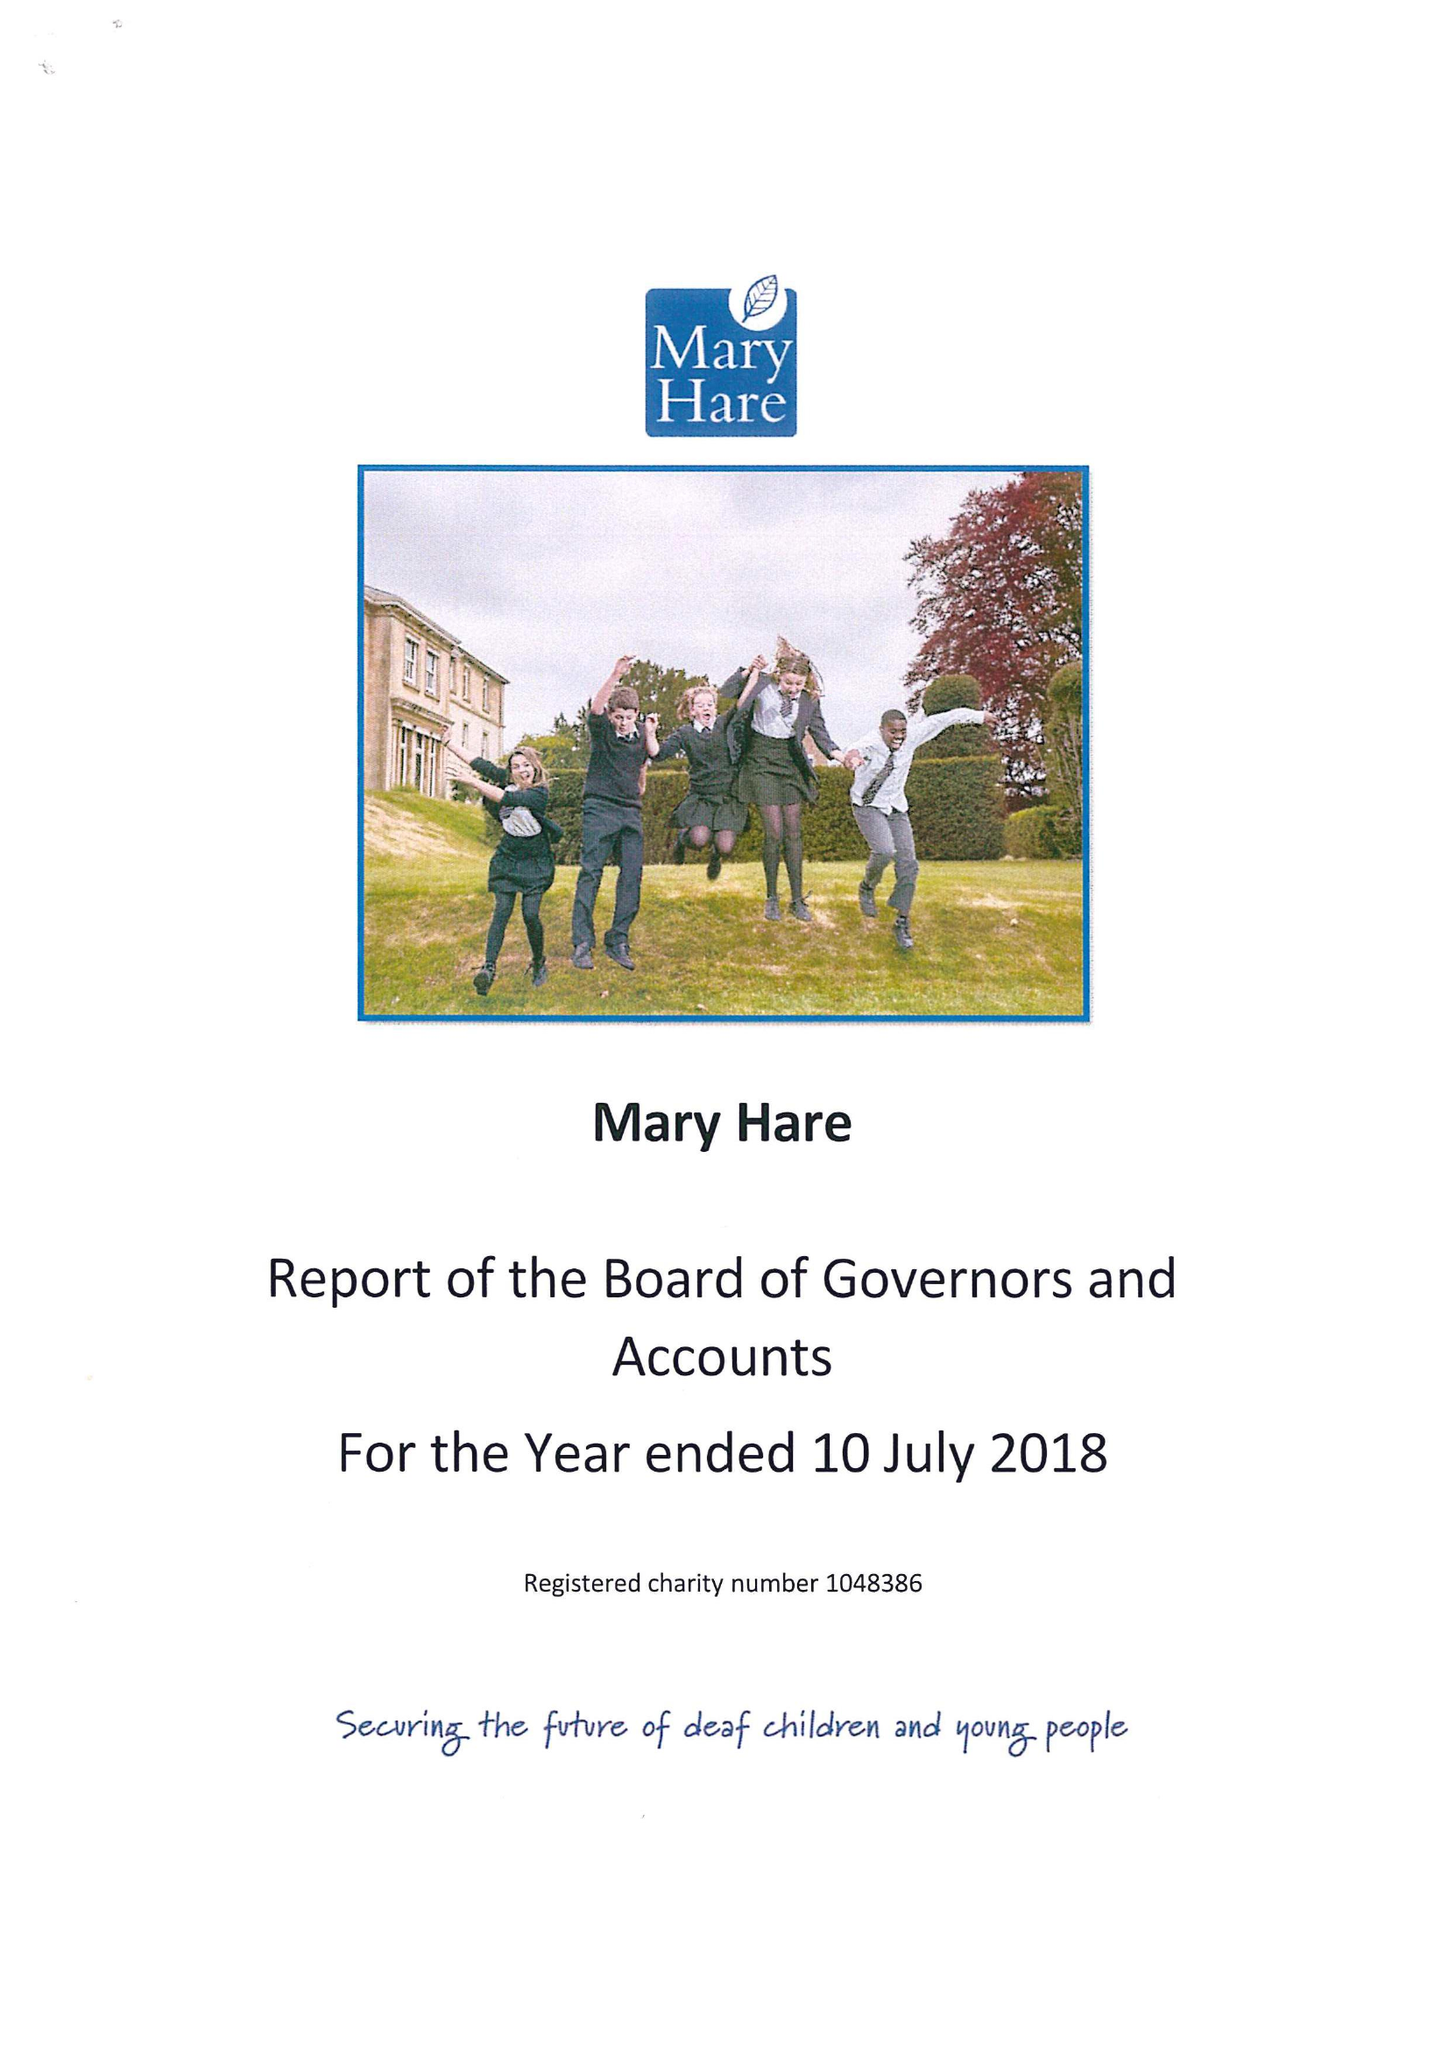What is the value for the address__post_town?
Answer the question using a single word or phrase. NEWBURY 